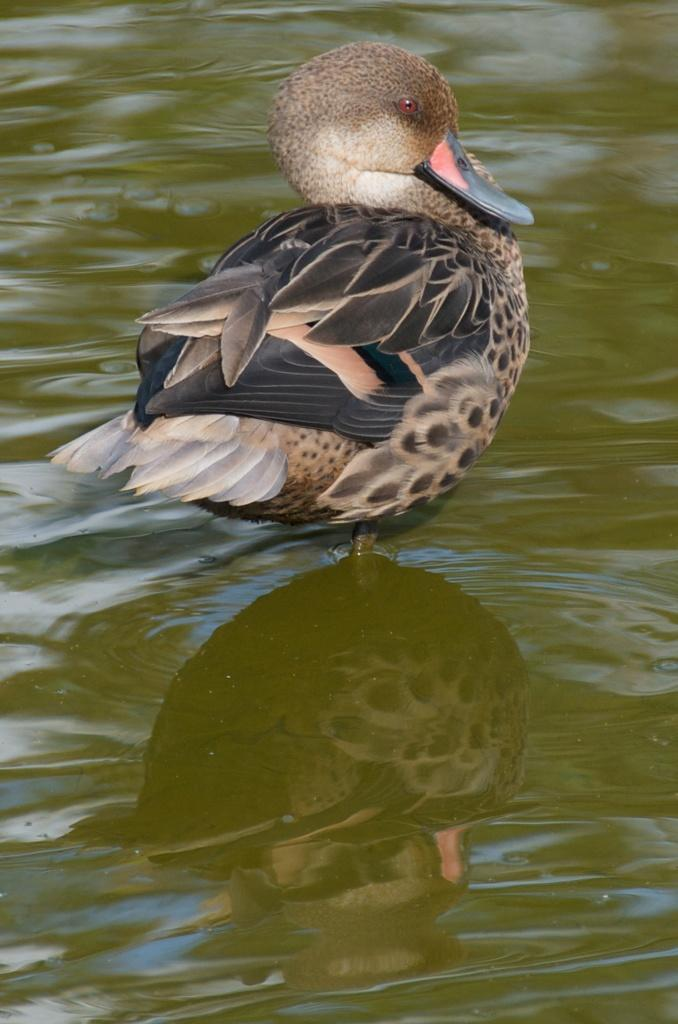What animal is present in the image? There is a duck in the image. Where is the duck located in the image? The duck is standing in the water. What type of holiday is the duck celebrating in the image? There is no indication of a holiday in the image, as it only features a duck standing in the water. 